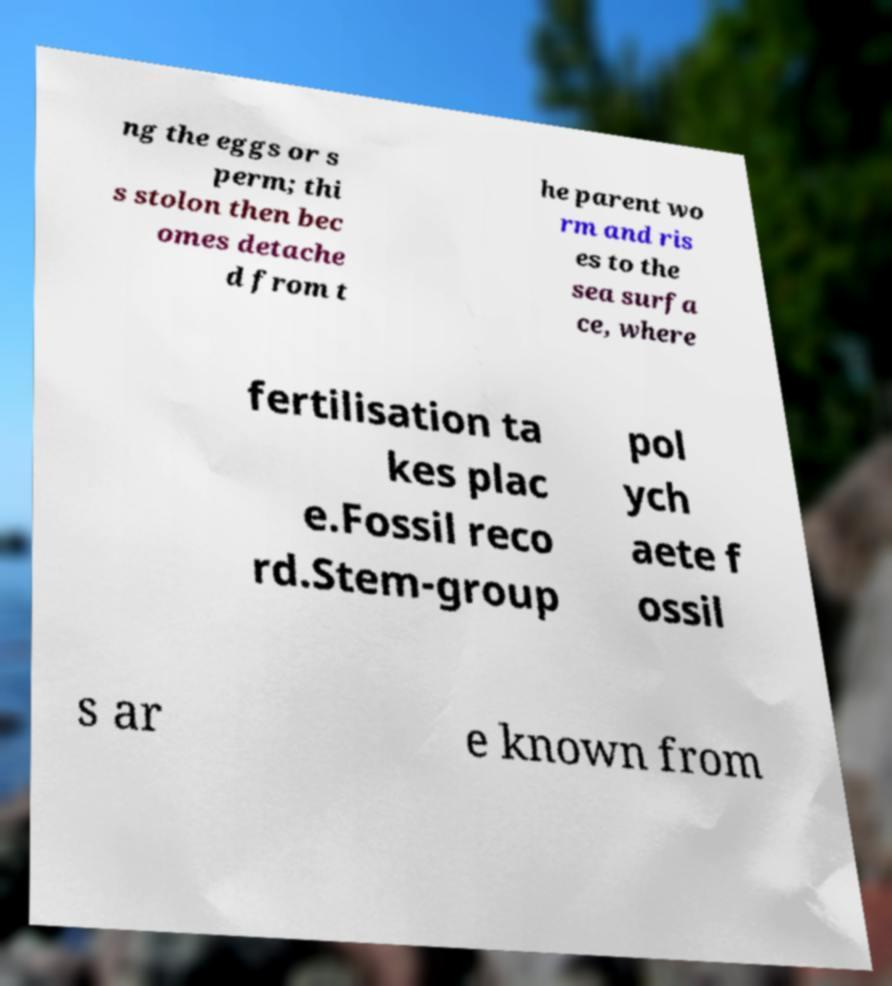For documentation purposes, I need the text within this image transcribed. Could you provide that? ng the eggs or s perm; thi s stolon then bec omes detache d from t he parent wo rm and ris es to the sea surfa ce, where fertilisation ta kes plac e.Fossil reco rd.Stem-group pol ych aete f ossil s ar e known from 